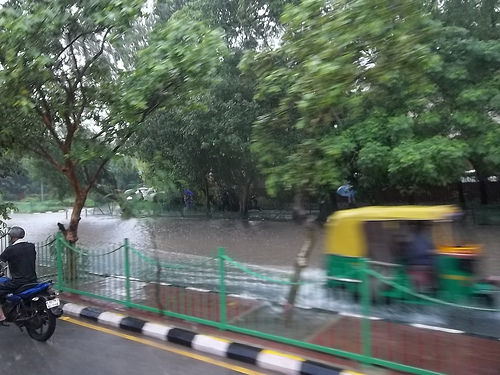<image>
Is the tree in the water? Yes. The tree is contained within or inside the water, showing a containment relationship. 